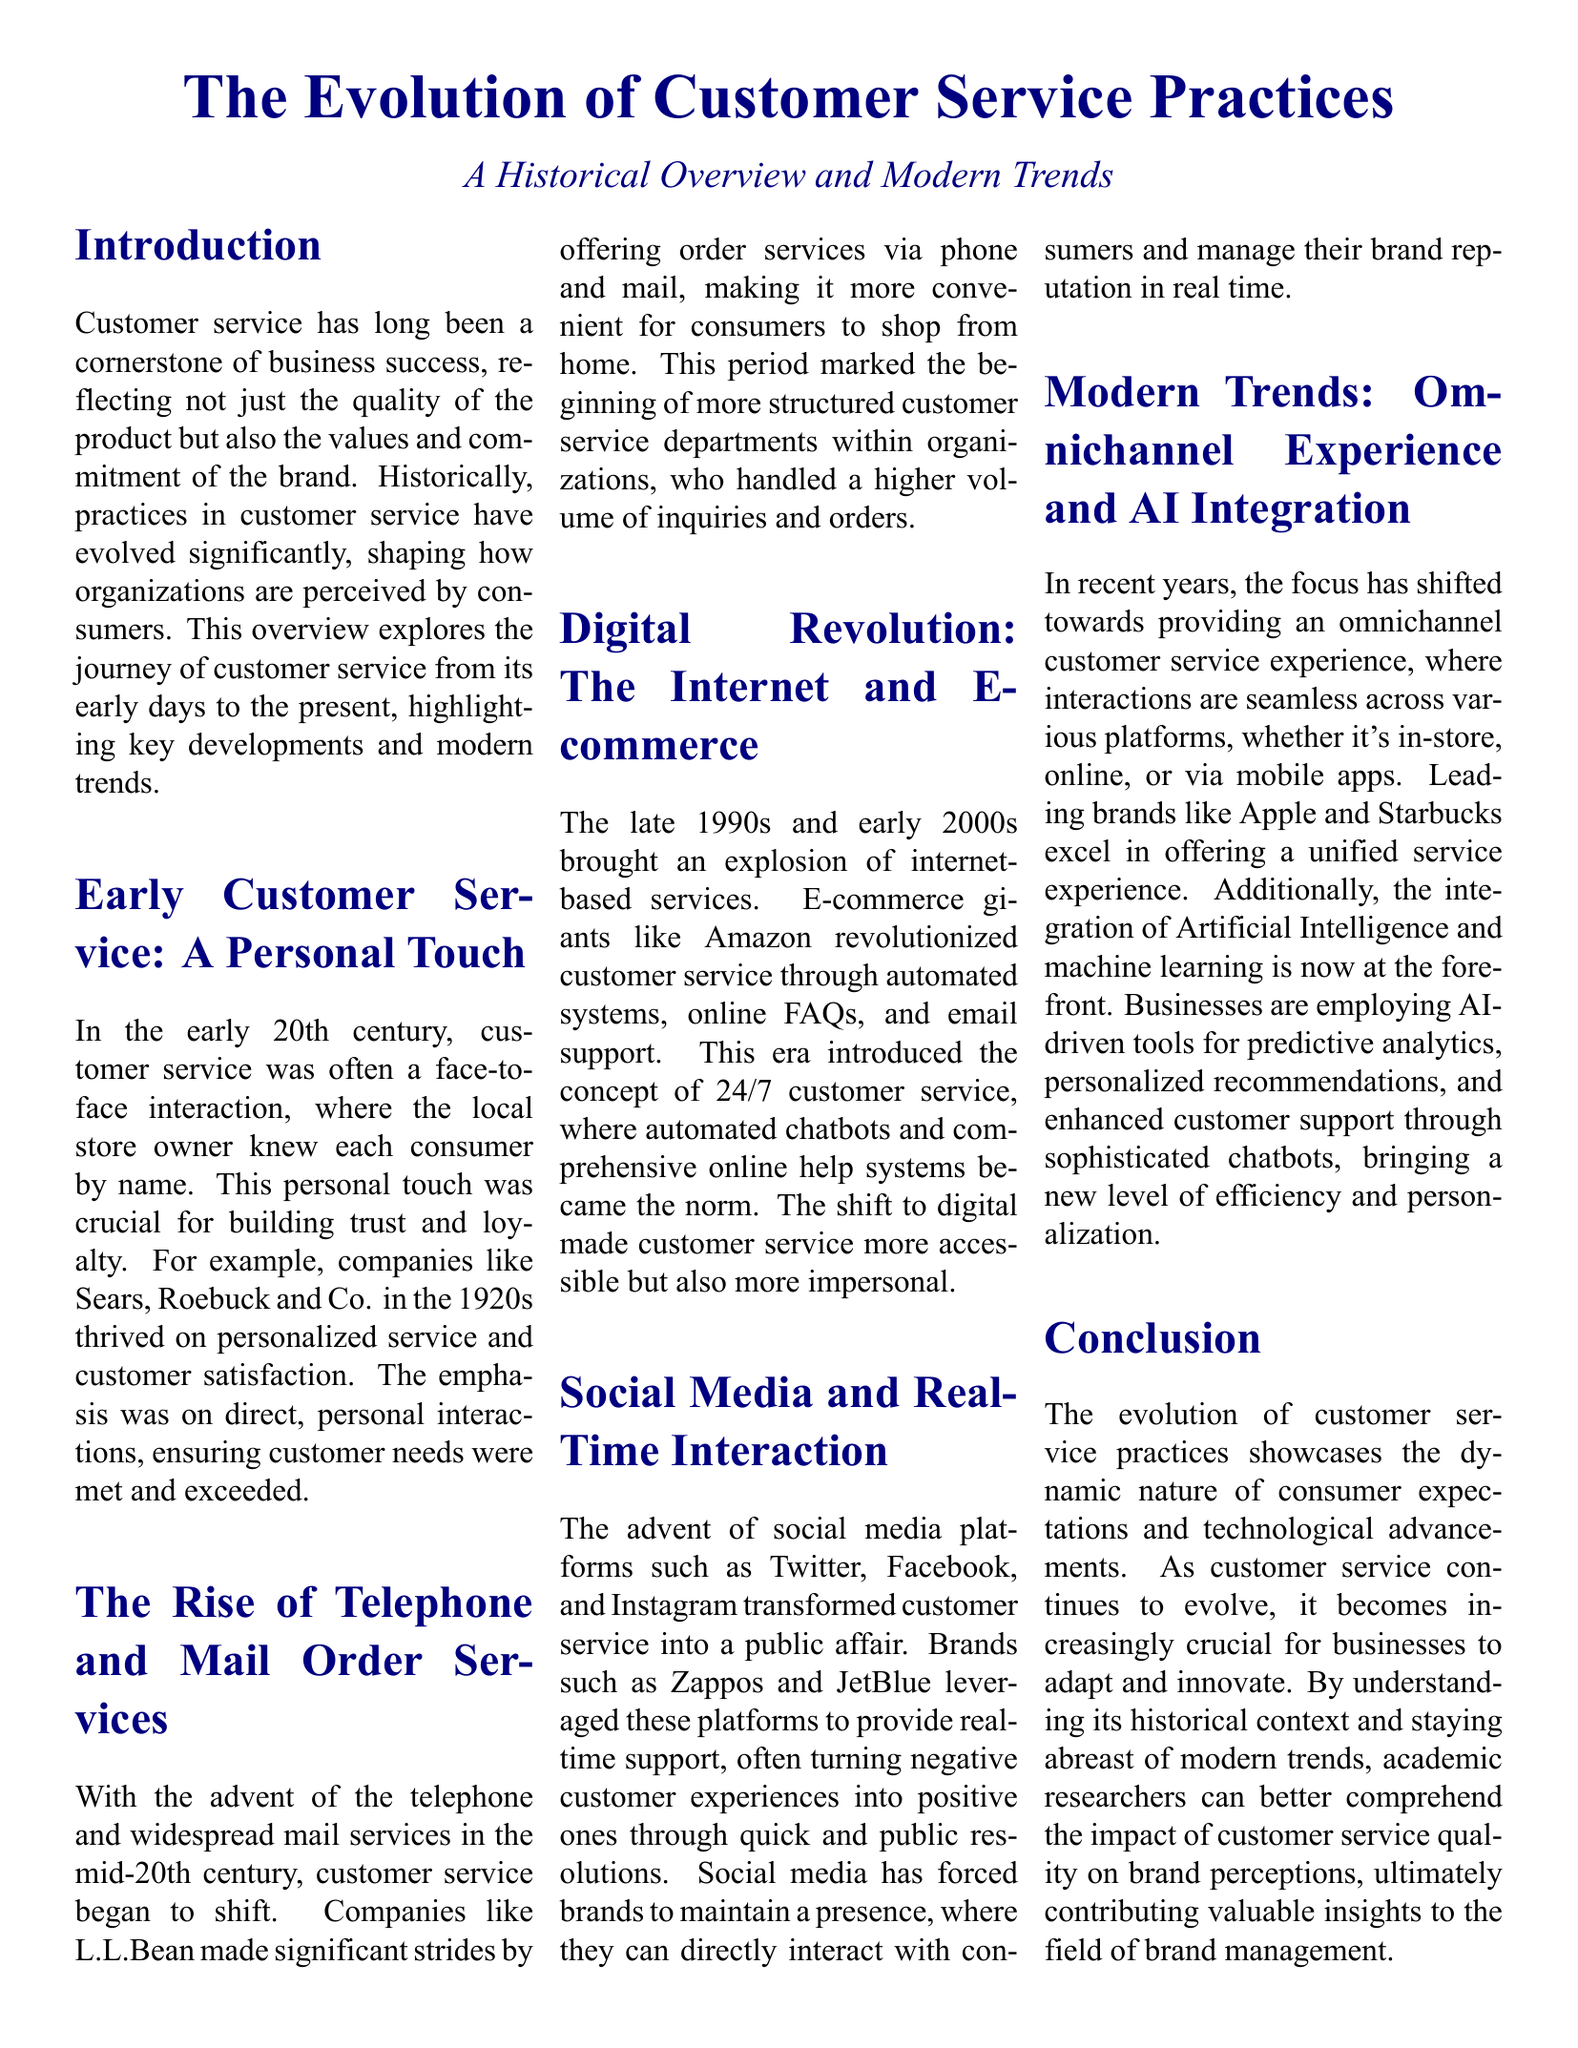What was a crucial aspect of early customer service? Early customer service was characterized by face-to-face interactions and the store owner knew consumers by name.
Answer: Personal touch Which company is mentioned for thriving on personalized service in the 1920s? The document references Sears, Roebuck and Co. as a company that excelled in personalized service during the 1920s.
Answer: Sears, Roebuck and Co When did customer service begin to shift with the advent of the telephone? The shift in customer service practices began in the mid-20th century with the introduction of the telephone.
Answer: Mid-20th century Which e-commerce giant is mentioned for revolutionizing customer service in the late 1990s? Amazon is identified as the e-commerce giant that transformed customer service through online systems.
Answer: Amazon What modern trend focuses on seamless experiences across various platforms? The document discusses the trend of providing an omnichannel customer service experience as a current focus.
Answer: Omnichannel experience What role do AI-driven tools play in modern customer service? The document states that AI-driven tools are employed for predictive analytics and enhanced customer support.
Answer: Efficiency and personalization What year range does the document refer to for the digital revolution in customer service? The digital revolution is discussed in the context of the late 1990s and early 2000s.
Answer: Late 1990s to early 2000s Which platform has transformed customer service into a public affair? Social media platforms like Twitter and Facebook have changed customer service interactions into public engagements.
Answer: Social media What is the impact of social media on brand reputation management? Brands are required to maintain a presence on social media to directly interact with consumers and manage reputation.
Answer: Real-time interaction 